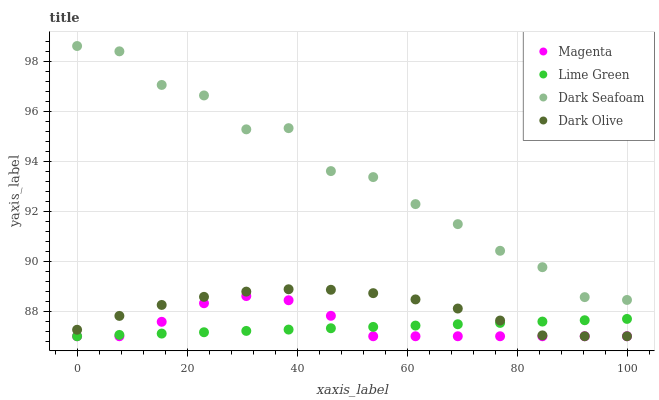Does Lime Green have the minimum area under the curve?
Answer yes or no. Yes. Does Dark Seafoam have the maximum area under the curve?
Answer yes or no. Yes. Does Dark Olive have the minimum area under the curve?
Answer yes or no. No. Does Dark Olive have the maximum area under the curve?
Answer yes or no. No. Is Lime Green the smoothest?
Answer yes or no. Yes. Is Dark Seafoam the roughest?
Answer yes or no. Yes. Is Dark Olive the smoothest?
Answer yes or no. No. Is Dark Olive the roughest?
Answer yes or no. No. Does Magenta have the lowest value?
Answer yes or no. Yes. Does Dark Seafoam have the lowest value?
Answer yes or no. No. Does Dark Seafoam have the highest value?
Answer yes or no. Yes. Does Dark Olive have the highest value?
Answer yes or no. No. Is Dark Olive less than Dark Seafoam?
Answer yes or no. Yes. Is Dark Seafoam greater than Magenta?
Answer yes or no. Yes. Does Magenta intersect Dark Olive?
Answer yes or no. Yes. Is Magenta less than Dark Olive?
Answer yes or no. No. Is Magenta greater than Dark Olive?
Answer yes or no. No. Does Dark Olive intersect Dark Seafoam?
Answer yes or no. No. 